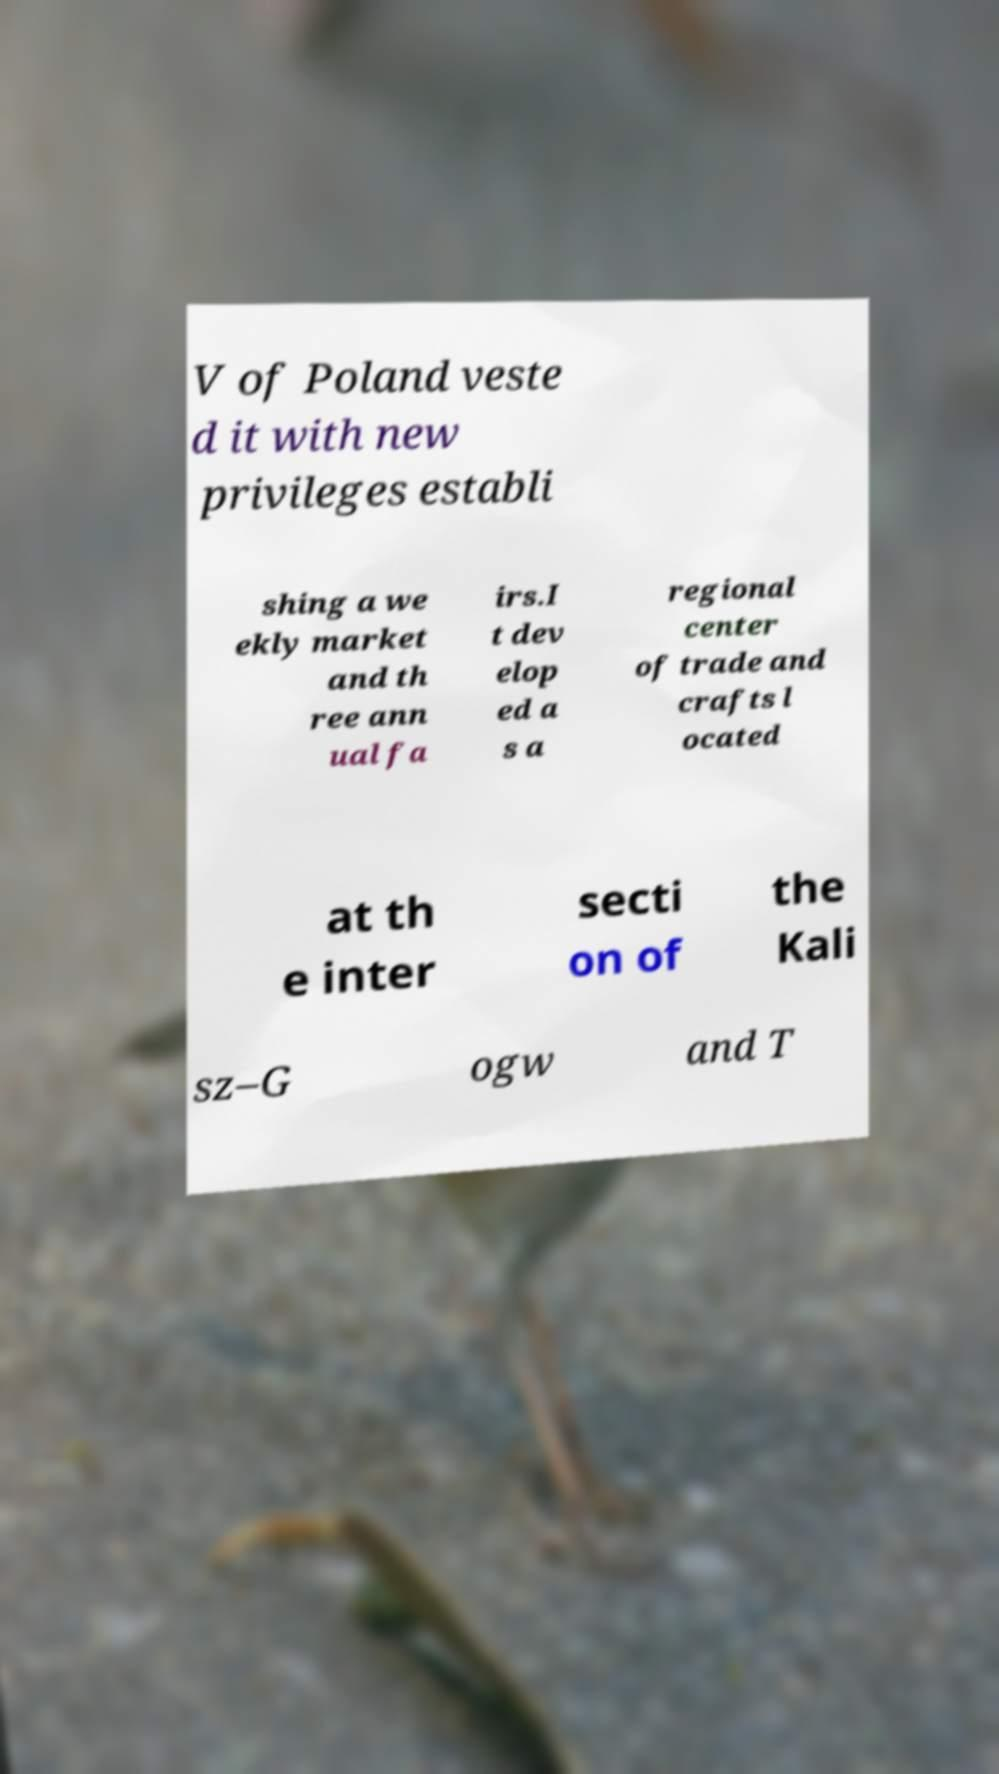Can you read and provide the text displayed in the image?This photo seems to have some interesting text. Can you extract and type it out for me? V of Poland veste d it with new privileges establi shing a we ekly market and th ree ann ual fa irs.I t dev elop ed a s a regional center of trade and crafts l ocated at th e inter secti on of the Kali sz–G ogw and T 